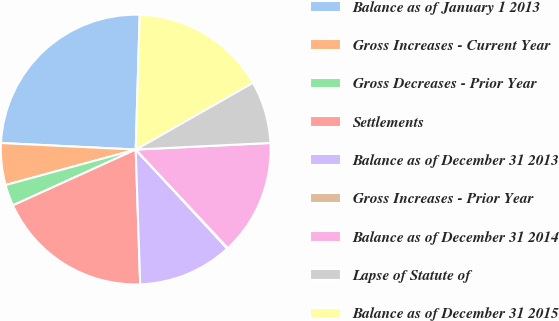Convert chart to OTSL. <chart><loc_0><loc_0><loc_500><loc_500><pie_chart><fcel>Balance as of January 1 2013<fcel>Gross Increases - Current Year<fcel>Gross Decreases - Prior Year<fcel>Settlements<fcel>Balance as of December 31 2013<fcel>Gross Increases - Prior Year<fcel>Balance as of December 31 2014<fcel>Lapse of Statute of<fcel>Balance as of December 31 2015<nl><fcel>24.7%<fcel>5.01%<fcel>2.55%<fcel>18.74%<fcel>11.35%<fcel>0.09%<fcel>13.81%<fcel>7.47%<fcel>16.28%<nl></chart> 